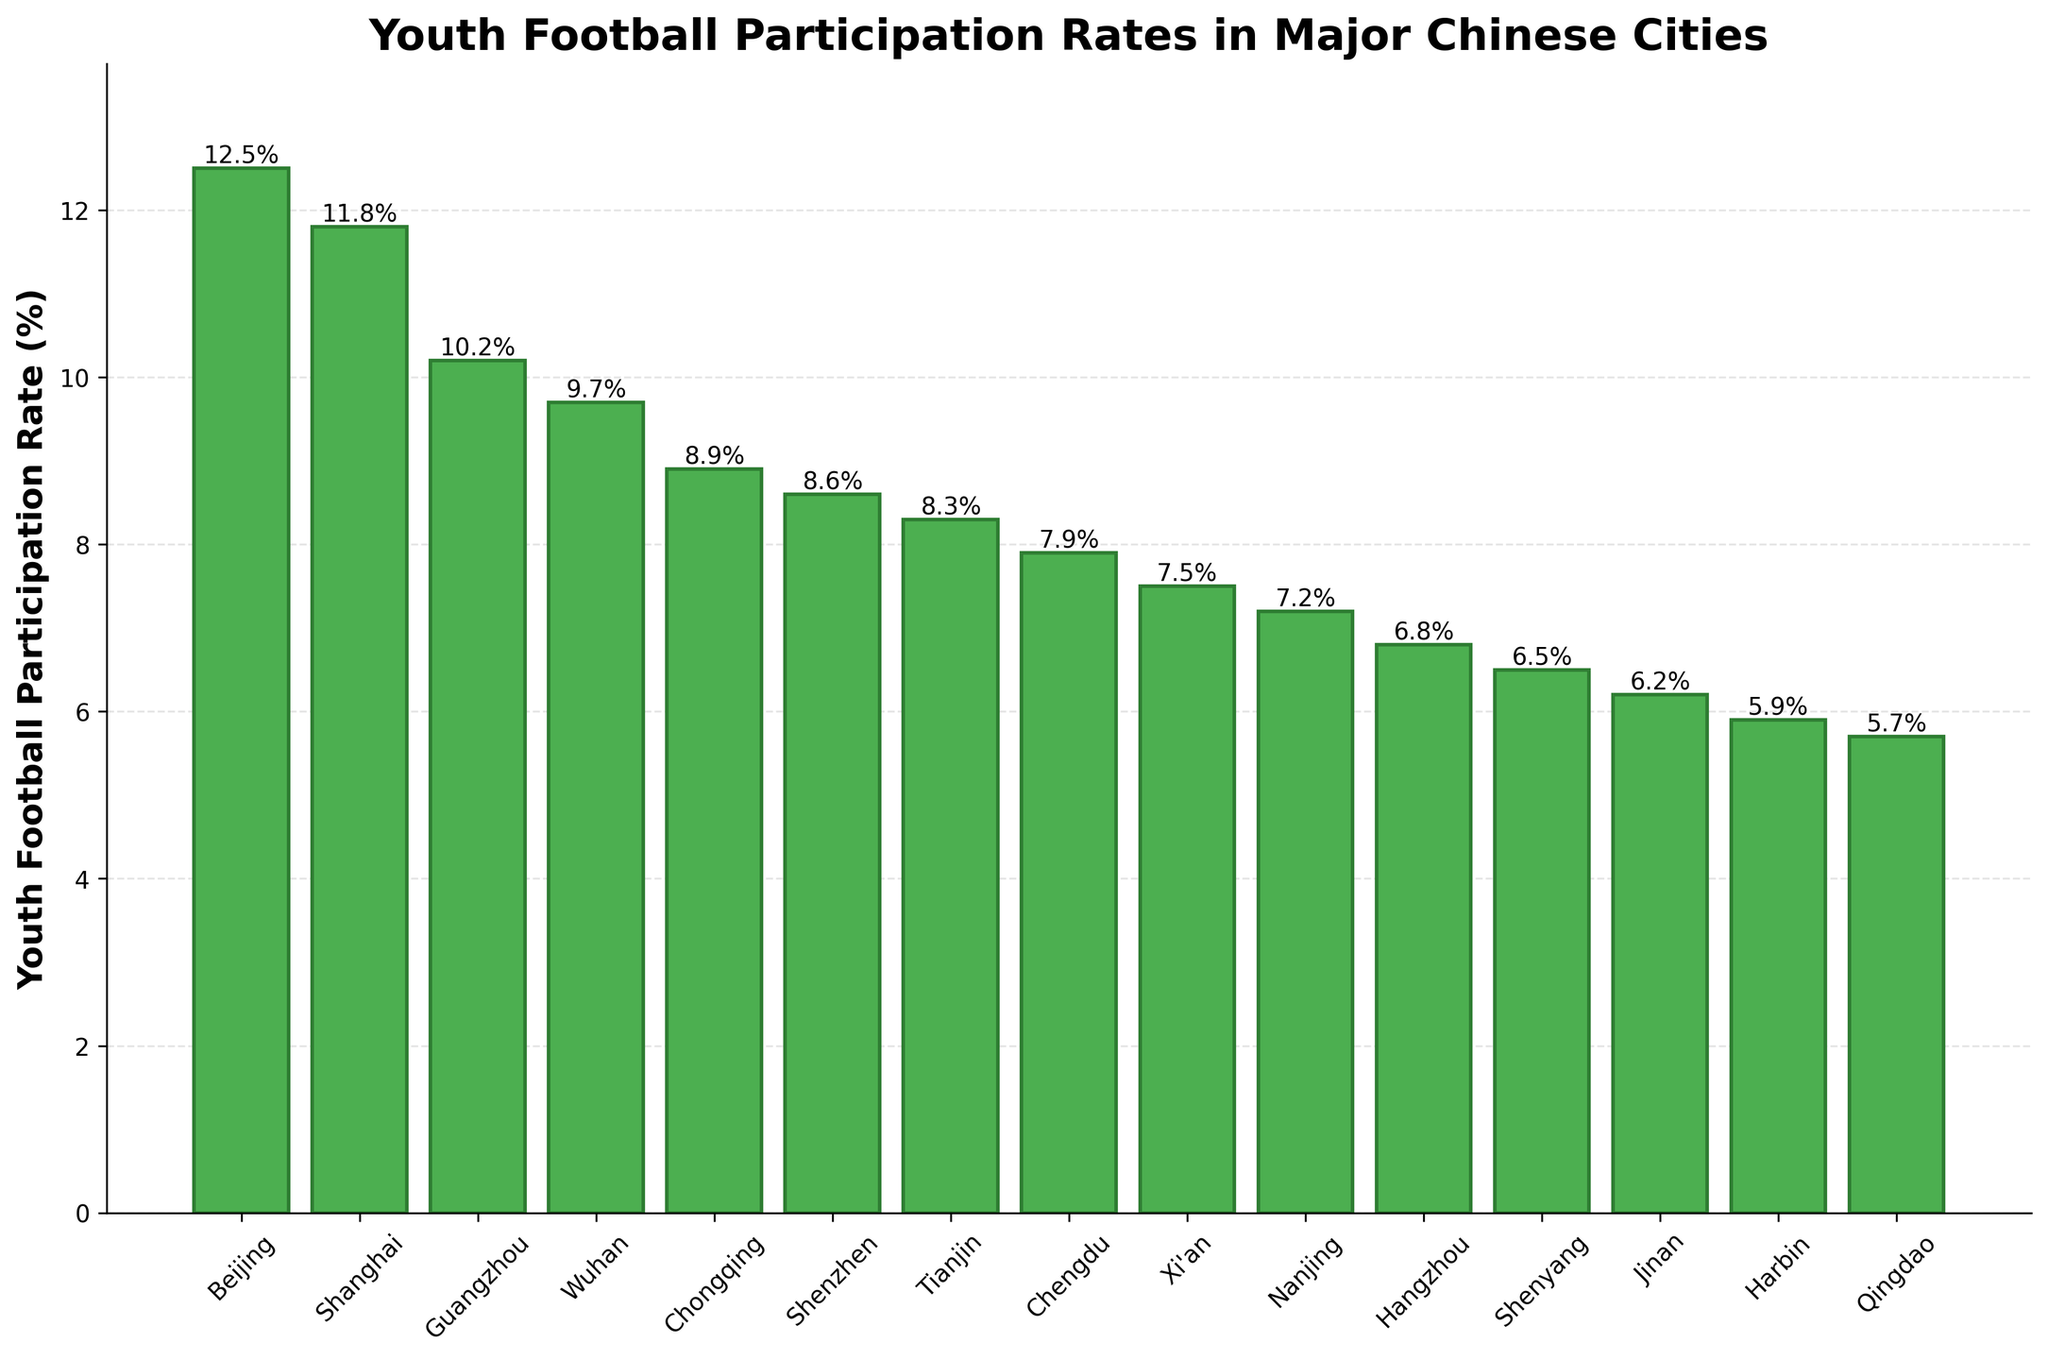What's the city with the highest youth football participation rate? By examining the bar chart, identify which bar is the tallest. The tallest bar is labeled "Beijing," representing the highest rate at 12.5%.
Answer: Beijing Which city's youth football participation rate is the closest to 10%? Inspect the bars around the 10% height mark and look for the closest value. The bar corresponding to Guangzhou is labeled 10.2%, which is closest to 10%.
Answer: Guangzhou What is the difference in participation rates between the city with the highest rate and the city with the lowest rate? The highest rate is 12.5% in Beijing and the lowest rate is 5.7% in Qingdao. Calculate the difference: 12.5% - 5.7% = 6.8%.
Answer: 6.8% How many cities have youth participation rates higher than 7%? Count the number of bars that extend above the 7% mark. The cities are Beijing, Shanghai, Guangzhou, Wuhan, Chongqing, Shenzhen, Tianjin, Chengdu and Xi'an. This totals to 9 cities.
Answer: 9 How much higher is Beijing's participation rate compared to Hangzhou's? Check the values for Beijing (12.5%) and Hangzhou (6.8%). The difference is calculated as 12.5% - 6.8% = 5.7%.
Answer: 5.7% Which city has a lower youth football participation rate than both Tianjin and Shenzhen? Identify Tianjin (8.3%) and Shenzhen (8.6%) and then find the city with a rate lower than both of these values. Hangzhou has a rate of 6.8%, which is lower than both Tianjin and Shenzhen.
Answer: Hangzhou What is the total participation rate of the three cities with the highest rates? Add the rates of Beijing (12.5%), Shanghai (11.8%), and Guangzhou (10.2%). The sum is 12.5% + 11.8% + 10.2% = 34.5%.
Answer: 34.5% Which city ranks fourth in terms of youth football participation rate? Identify the descending order of participation rates. The fourth highest rate is 9.7%, which corresponds to Wuhan.
Answer: Wuhan What is the combined youth football participation rate for cities in excess of 8% but less than 10%? Identify cities with participation rates between 8% and 10%: Wuhan (9.7%), Chongqing (8.9%), Shenzhen (8.6%), and Tianjin (8.3%). Sum their rates: 9.7% + 8.9% + 8.6% + 8.3% = 35.5%.
Answer: 35.5% If the participation rates for Beijing and Harbin were combined, what would their total be? Add the rates for Beijing (12.5%) and Harbin (5.9%). The sum is 12.5% + 5.9% = 18.4%.
Answer: 18.4% 